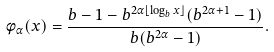Convert formula to latex. <formula><loc_0><loc_0><loc_500><loc_500>\phi _ { \alpha } ( x ) = \frac { b - 1 - b ^ { 2 \alpha \lfloor \log _ { b } x \rfloor } ( b ^ { 2 \alpha + 1 } - 1 ) } { b ( b ^ { 2 \alpha } - 1 ) } .</formula> 